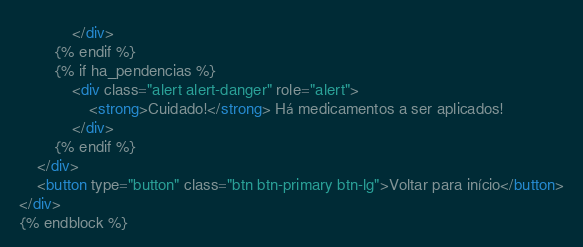Convert code to text. <code><loc_0><loc_0><loc_500><loc_500><_HTML_>            </div>
        {% endif %}
        {% if ha_pendencias %}
            <div class="alert alert-danger" role="alert">
                <strong>Cuidado!</strong> Há medicamentos a ser aplicados!
            </div>
        {% endif %}
    </div>
    <button type="button" class="btn btn-primary btn-lg">Voltar para início</button>
</div>
{% endblock %}</code> 